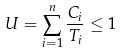<formula> <loc_0><loc_0><loc_500><loc_500>U = \sum _ { i = 1 } ^ { n } \frac { C _ { i } } { T _ { i } } \leq 1</formula> 